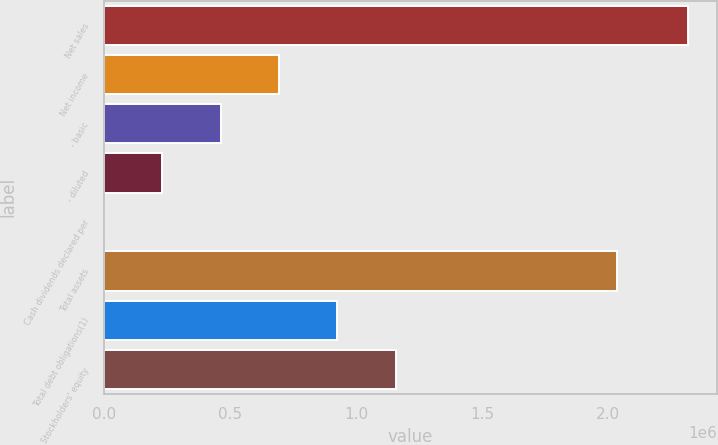Convert chart to OTSL. <chart><loc_0><loc_0><loc_500><loc_500><bar_chart><fcel>Net sales<fcel>Net income<fcel>- basic<fcel>- diluted<fcel>Cash dividends declared per<fcel>Total assets<fcel>Total debt obligations(1)<fcel>Stockholders' equity<nl><fcel>2.31601e+06<fcel>694803<fcel>463202<fcel>231602<fcel>1.05<fcel>2.03586e+06<fcel>926403<fcel>1.158e+06<nl></chart> 